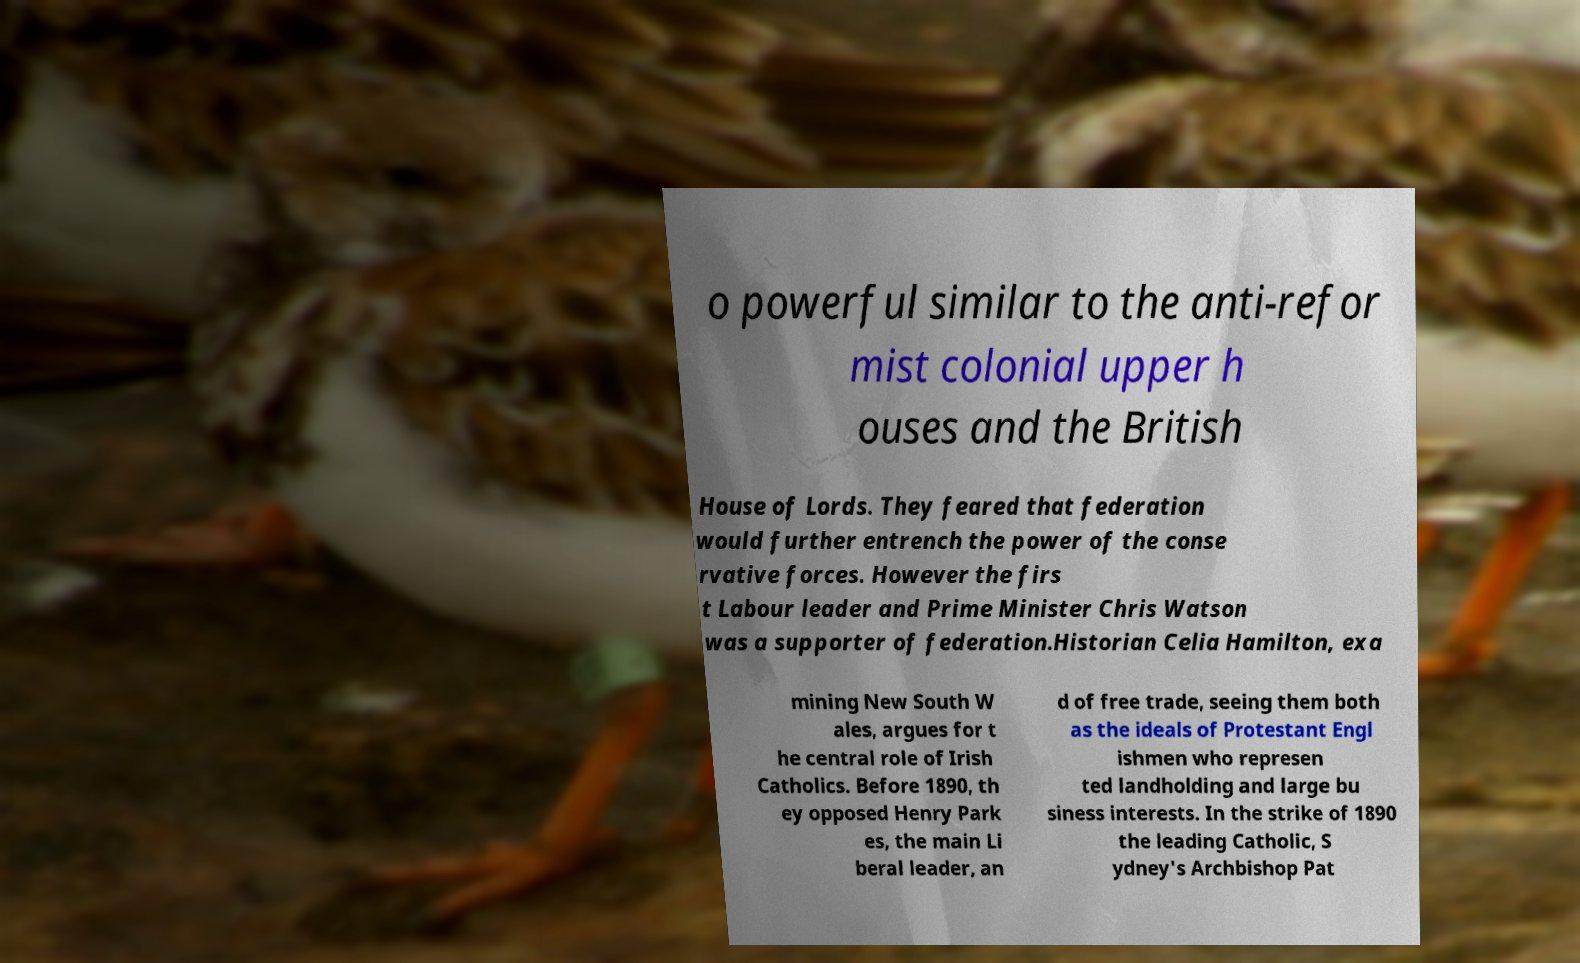Please identify and transcribe the text found in this image. o powerful similar to the anti-refor mist colonial upper h ouses and the British House of Lords. They feared that federation would further entrench the power of the conse rvative forces. However the firs t Labour leader and Prime Minister Chris Watson was a supporter of federation.Historian Celia Hamilton, exa mining New South W ales, argues for t he central role of Irish Catholics. Before 1890, th ey opposed Henry Park es, the main Li beral leader, an d of free trade, seeing them both as the ideals of Protestant Engl ishmen who represen ted landholding and large bu siness interests. In the strike of 1890 the leading Catholic, S ydney's Archbishop Pat 